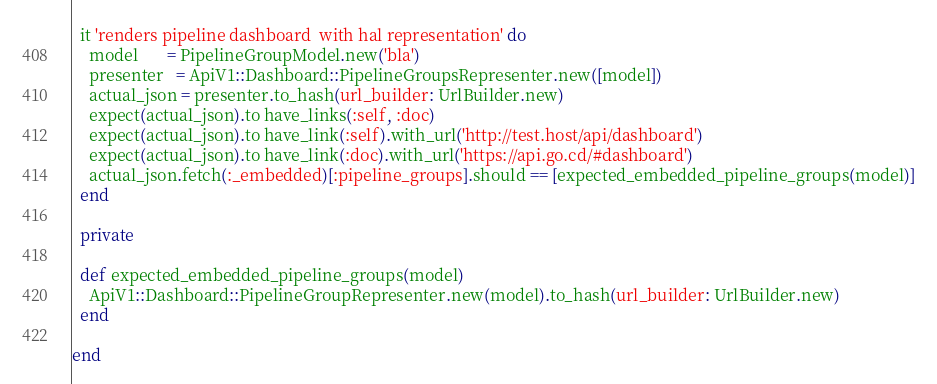Convert code to text. <code><loc_0><loc_0><loc_500><loc_500><_Ruby_>
  it 'renders pipeline dashboard  with hal representation' do
    model       = PipelineGroupModel.new('bla')
    presenter   = ApiV1::Dashboard::PipelineGroupsRepresenter.new([model])
    actual_json = presenter.to_hash(url_builder: UrlBuilder.new)
    expect(actual_json).to have_links(:self, :doc)
    expect(actual_json).to have_link(:self).with_url('http://test.host/api/dashboard')
    expect(actual_json).to have_link(:doc).with_url('https://api.go.cd/#dashboard')
    actual_json.fetch(:_embedded)[:pipeline_groups].should == [expected_embedded_pipeline_groups(model)]
  end

  private

  def expected_embedded_pipeline_groups(model)
    ApiV1::Dashboard::PipelineGroupRepresenter.new(model).to_hash(url_builder: UrlBuilder.new)
  end

end
</code> 